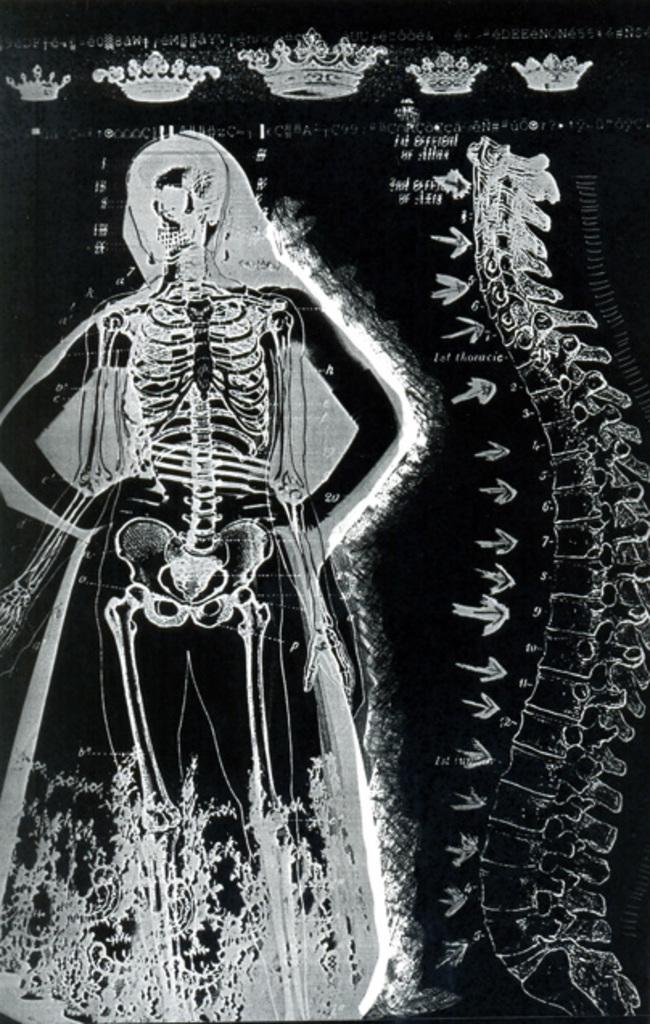What type of images can be seen in the picture? There are graphic images of skeletons and images of vertebrae in the image. Are there any specific features of the skeletons shown? Yes, there are different types of crowns depicted in the image. What type of butter is being used to decorate the fairies in the image? There are no fairies or butter present in the image; it features graphic images of skeletons and vertebrae with different types of crowns. 